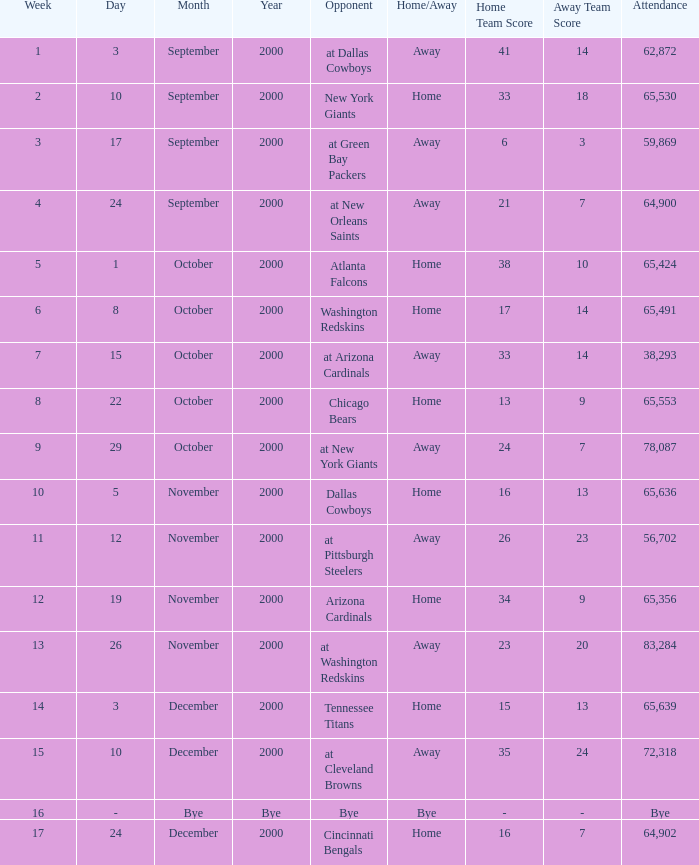What was the attendance when the Cincinnati Bengals were the opponents? 64902.0. 